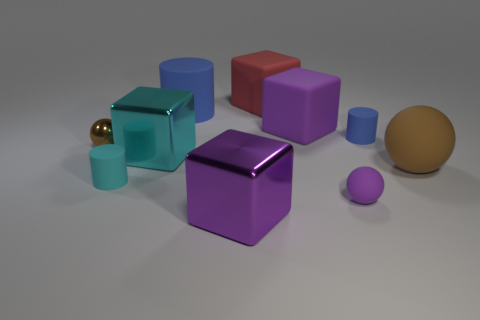Subtract 1 blocks. How many blocks are left? 3 Subtract all cubes. How many objects are left? 6 Subtract 0 cyan spheres. How many objects are left? 10 Subtract all purple rubber balls. Subtract all small metallic objects. How many objects are left? 8 Add 8 tiny purple rubber spheres. How many tiny purple rubber spheres are left? 9 Add 9 large rubber spheres. How many large rubber spheres exist? 10 